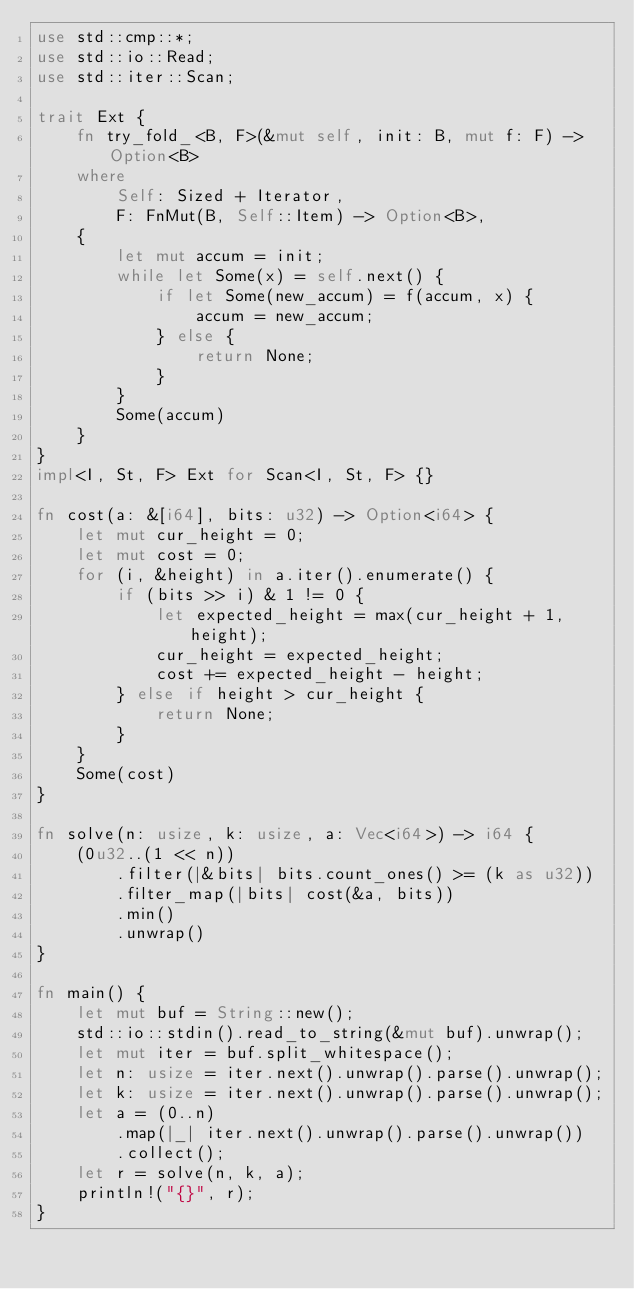Convert code to text. <code><loc_0><loc_0><loc_500><loc_500><_Rust_>use std::cmp::*;
use std::io::Read;
use std::iter::Scan;

trait Ext {
    fn try_fold_<B, F>(&mut self, init: B, mut f: F) -> Option<B>
    where
        Self: Sized + Iterator,
        F: FnMut(B, Self::Item) -> Option<B>,
    {
        let mut accum = init;
        while let Some(x) = self.next() {
            if let Some(new_accum) = f(accum, x) {
                accum = new_accum;
            } else {
                return None;
            }
        }
        Some(accum)
    }
}
impl<I, St, F> Ext for Scan<I, St, F> {}

fn cost(a: &[i64], bits: u32) -> Option<i64> {
    let mut cur_height = 0;
    let mut cost = 0;
    for (i, &height) in a.iter().enumerate() {
        if (bits >> i) & 1 != 0 {
            let expected_height = max(cur_height + 1, height);
            cur_height = expected_height;
            cost += expected_height - height;
        } else if height > cur_height {
            return None;
        }
    }
    Some(cost)
}

fn solve(n: usize, k: usize, a: Vec<i64>) -> i64 {
    (0u32..(1 << n))
        .filter(|&bits| bits.count_ones() >= (k as u32))
        .filter_map(|bits| cost(&a, bits))
        .min()
        .unwrap()
}

fn main() {
    let mut buf = String::new();
    std::io::stdin().read_to_string(&mut buf).unwrap();
    let mut iter = buf.split_whitespace();
    let n: usize = iter.next().unwrap().parse().unwrap();
    let k: usize = iter.next().unwrap().parse().unwrap();
    let a = (0..n)
        .map(|_| iter.next().unwrap().parse().unwrap())
        .collect();
    let r = solve(n, k, a);
    println!("{}", r);
}
</code> 